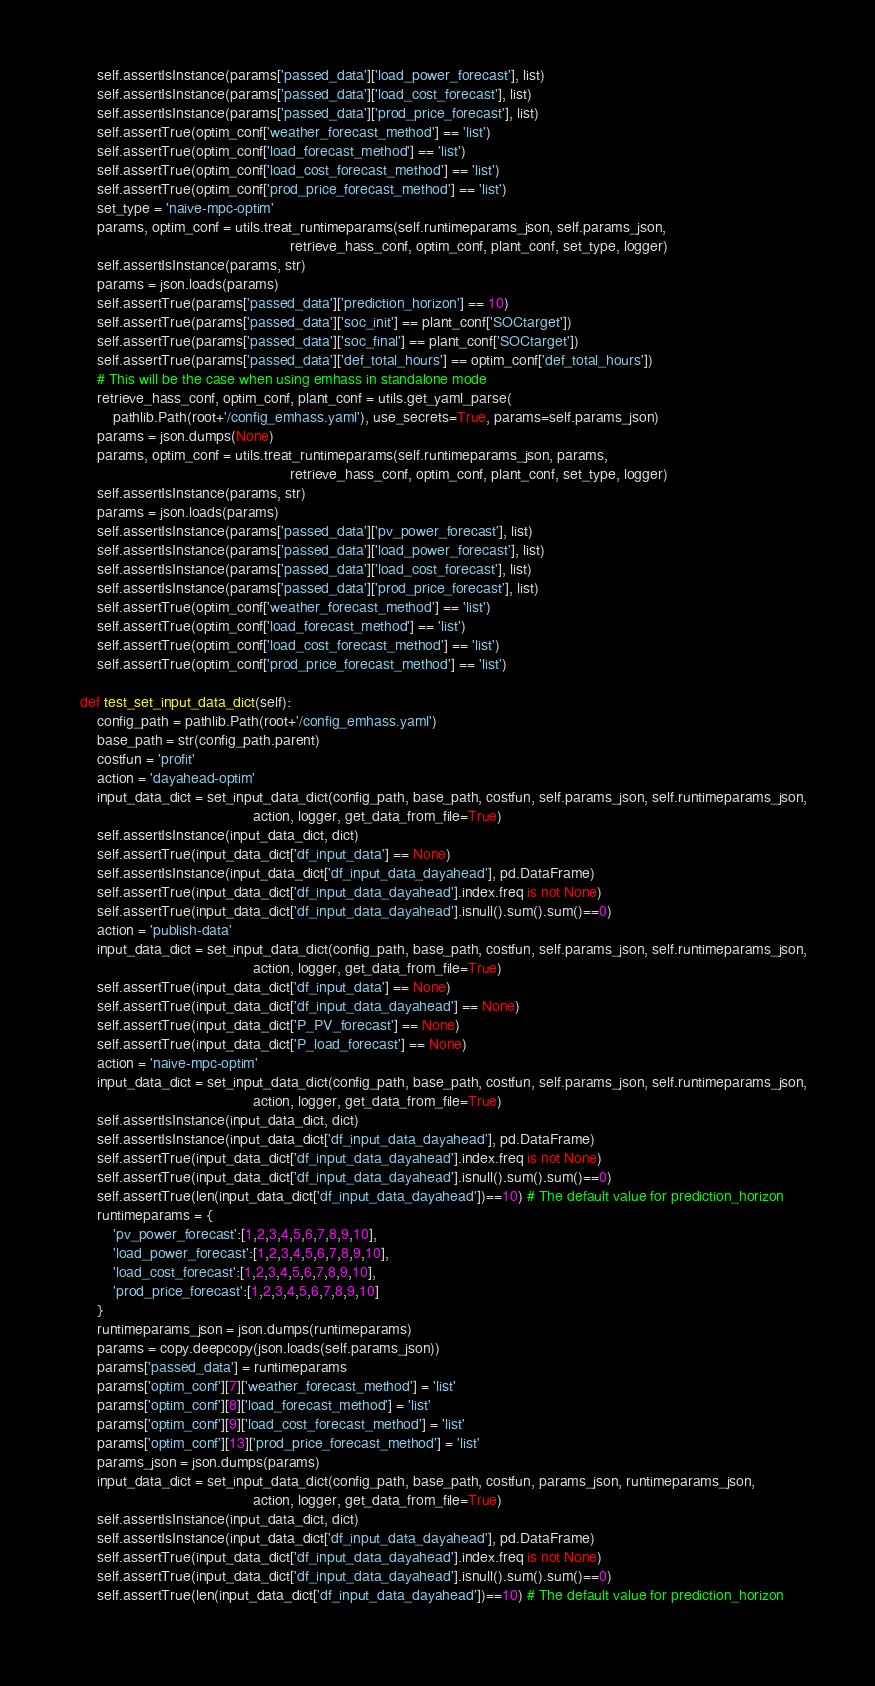<code> <loc_0><loc_0><loc_500><loc_500><_Python_>        self.assertIsInstance(params['passed_data']['load_power_forecast'], list)
        self.assertIsInstance(params['passed_data']['load_cost_forecast'], list)
        self.assertIsInstance(params['passed_data']['prod_price_forecast'], list)
        self.assertTrue(optim_conf['weather_forecast_method'] == 'list')
        self.assertTrue(optim_conf['load_forecast_method'] == 'list')
        self.assertTrue(optim_conf['load_cost_forecast_method'] == 'list')
        self.assertTrue(optim_conf['prod_price_forecast_method'] == 'list')
        set_type = 'naive-mpc-optim'
        params, optim_conf = utils.treat_runtimeparams(self.runtimeparams_json, self.params_json, 
                                                       retrieve_hass_conf, optim_conf, plant_conf, set_type, logger)
        self.assertIsInstance(params, str)
        params = json.loads(params)
        self.assertTrue(params['passed_data']['prediction_horizon'] == 10)
        self.assertTrue(params['passed_data']['soc_init'] == plant_conf['SOCtarget'])
        self.assertTrue(params['passed_data']['soc_final'] == plant_conf['SOCtarget'])
        self.assertTrue(params['passed_data']['def_total_hours'] == optim_conf['def_total_hours'])
        # This will be the case when using emhass in standalone mode
        retrieve_hass_conf, optim_conf, plant_conf = utils.get_yaml_parse(
            pathlib.Path(root+'/config_emhass.yaml'), use_secrets=True, params=self.params_json)
        params = json.dumps(None)
        params, optim_conf = utils.treat_runtimeparams(self.runtimeparams_json, params, 
                                                       retrieve_hass_conf, optim_conf, plant_conf, set_type, logger)
        self.assertIsInstance(params, str)
        params = json.loads(params)
        self.assertIsInstance(params['passed_data']['pv_power_forecast'], list)
        self.assertIsInstance(params['passed_data']['load_power_forecast'], list)
        self.assertIsInstance(params['passed_data']['load_cost_forecast'], list)
        self.assertIsInstance(params['passed_data']['prod_price_forecast'], list)
        self.assertTrue(optim_conf['weather_forecast_method'] == 'list')
        self.assertTrue(optim_conf['load_forecast_method'] == 'list')
        self.assertTrue(optim_conf['load_cost_forecast_method'] == 'list')
        self.assertTrue(optim_conf['prod_price_forecast_method'] == 'list')
        
    def test_set_input_data_dict(self):
        config_path = pathlib.Path(root+'/config_emhass.yaml')
        base_path = str(config_path.parent)
        costfun = 'profit'
        action = 'dayahead-optim'
        input_data_dict = set_input_data_dict(config_path, base_path, costfun, self.params_json, self.runtimeparams_json, 
                                              action, logger, get_data_from_file=True)
        self.assertIsInstance(input_data_dict, dict)
        self.assertTrue(input_data_dict['df_input_data'] == None)
        self.assertIsInstance(input_data_dict['df_input_data_dayahead'], pd.DataFrame)
        self.assertTrue(input_data_dict['df_input_data_dayahead'].index.freq is not None)
        self.assertTrue(input_data_dict['df_input_data_dayahead'].isnull().sum().sum()==0)
        action = 'publish-data'
        input_data_dict = set_input_data_dict(config_path, base_path, costfun, self.params_json, self.runtimeparams_json, 
                                              action, logger, get_data_from_file=True)
        self.assertTrue(input_data_dict['df_input_data'] == None)
        self.assertTrue(input_data_dict['df_input_data_dayahead'] == None)
        self.assertTrue(input_data_dict['P_PV_forecast'] == None)
        self.assertTrue(input_data_dict['P_load_forecast'] == None)
        action = 'naive-mpc-optim'
        input_data_dict = set_input_data_dict(config_path, base_path, costfun, self.params_json, self.runtimeparams_json, 
                                              action, logger, get_data_from_file=True)
        self.assertIsInstance(input_data_dict, dict)
        self.assertIsInstance(input_data_dict['df_input_data_dayahead'], pd.DataFrame)
        self.assertTrue(input_data_dict['df_input_data_dayahead'].index.freq is not None)
        self.assertTrue(input_data_dict['df_input_data_dayahead'].isnull().sum().sum()==0)
        self.assertTrue(len(input_data_dict['df_input_data_dayahead'])==10) # The default value for prediction_horizon
        runtimeparams = {
            'pv_power_forecast':[1,2,3,4,5,6,7,8,9,10],
            'load_power_forecast':[1,2,3,4,5,6,7,8,9,10],
            'load_cost_forecast':[1,2,3,4,5,6,7,8,9,10],
            'prod_price_forecast':[1,2,3,4,5,6,7,8,9,10]
        }
        runtimeparams_json = json.dumps(runtimeparams)
        params = copy.deepcopy(json.loads(self.params_json))
        params['passed_data'] = runtimeparams
        params['optim_conf'][7]['weather_forecast_method'] = 'list'
        params['optim_conf'][8]['load_forecast_method'] = 'list'
        params['optim_conf'][9]['load_cost_forecast_method'] = 'list'
        params['optim_conf'][13]['prod_price_forecast_method'] = 'list'
        params_json = json.dumps(params)
        input_data_dict = set_input_data_dict(config_path, base_path, costfun, params_json, runtimeparams_json, 
                                              action, logger, get_data_from_file=True)
        self.assertIsInstance(input_data_dict, dict)
        self.assertIsInstance(input_data_dict['df_input_data_dayahead'], pd.DataFrame)
        self.assertTrue(input_data_dict['df_input_data_dayahead'].index.freq is not None)
        self.assertTrue(input_data_dict['df_input_data_dayahead'].isnull().sum().sum()==0)
        self.assertTrue(len(input_data_dict['df_input_data_dayahead'])==10) # The default value for prediction_horizon
        </code> 